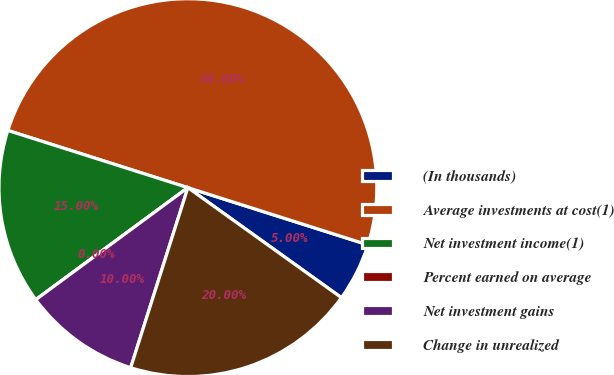Convert chart to OTSL. <chart><loc_0><loc_0><loc_500><loc_500><pie_chart><fcel>(In thousands)<fcel>Average investments at cost(1)<fcel>Net investment income(1)<fcel>Percent earned on average<fcel>Net investment gains<fcel>Change in unrealized<nl><fcel>5.0%<fcel>50.0%<fcel>15.0%<fcel>0.0%<fcel>10.0%<fcel>20.0%<nl></chart> 